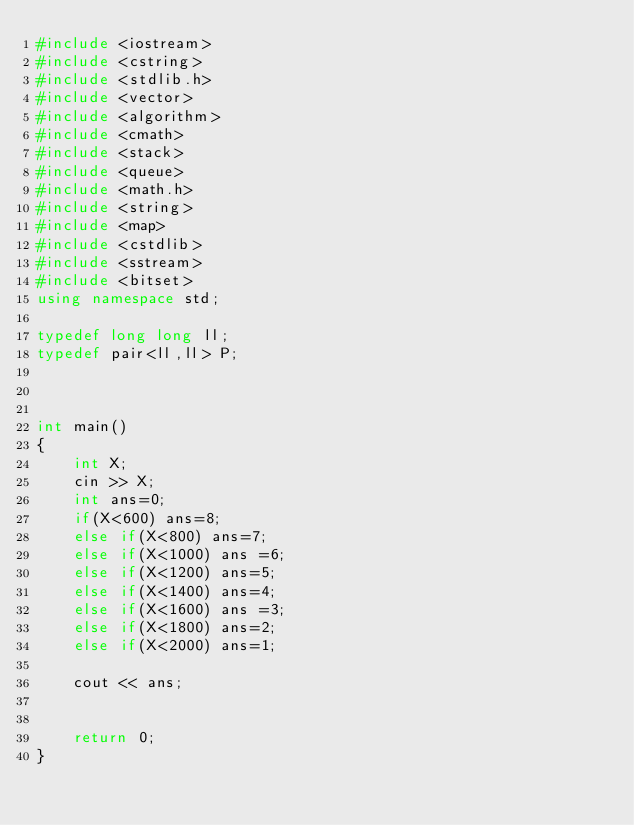<code> <loc_0><loc_0><loc_500><loc_500><_C++_>#include <iostream>
#include <cstring>
#include <stdlib.h>
#include <vector>
#include <algorithm>
#include <cmath>
#include <stack>
#include <queue>
#include <math.h>
#include <string>
#include <map>
#include <cstdlib>
#include <sstream>
#include <bitset>
using namespace std;

typedef long long ll;
typedef pair<ll,ll> P;



int main()
{
    int X;
    cin >> X;
    int ans=0;
    if(X<600) ans=8;
    else if(X<800) ans=7;
    else if(X<1000) ans =6;
    else if(X<1200) ans=5;
    else if(X<1400) ans=4;
    else if(X<1600) ans =3;
    else if(X<1800) ans=2;
    else if(X<2000) ans=1;

    cout << ans;


    return 0;
}</code> 